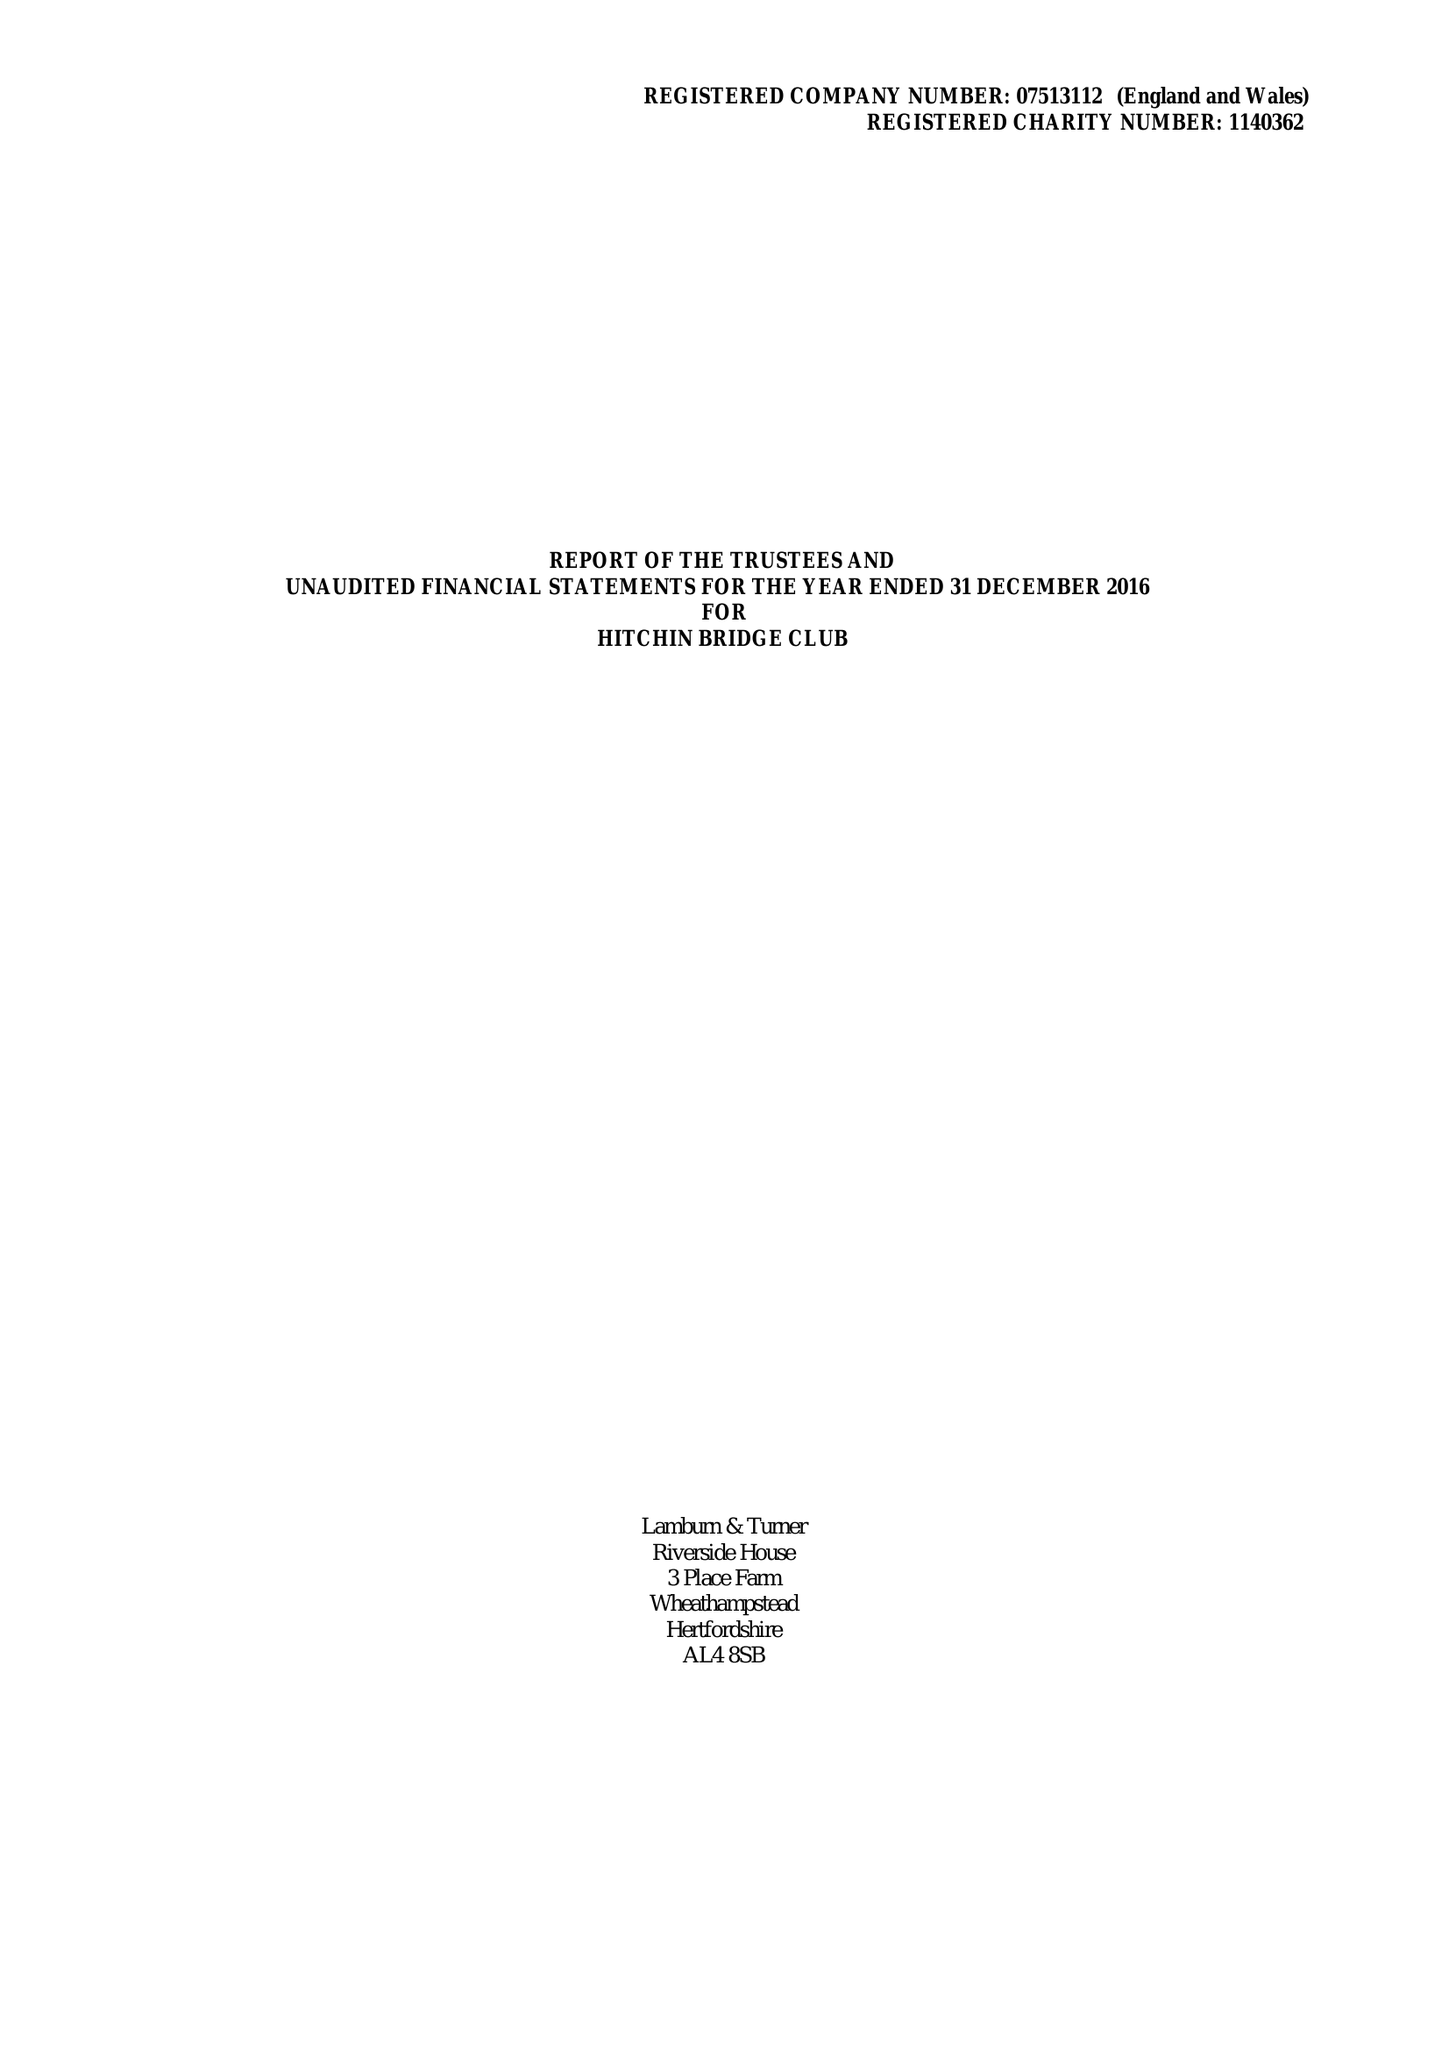What is the value for the income_annually_in_british_pounds?
Answer the question using a single word or phrase. 30731.00 